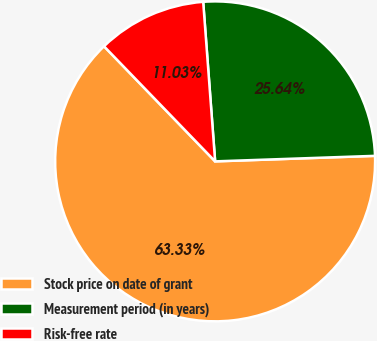Convert chart to OTSL. <chart><loc_0><loc_0><loc_500><loc_500><pie_chart><fcel>Stock price on date of grant<fcel>Measurement period (in years)<fcel>Risk-free rate<nl><fcel>63.33%<fcel>25.64%<fcel>11.03%<nl></chart> 